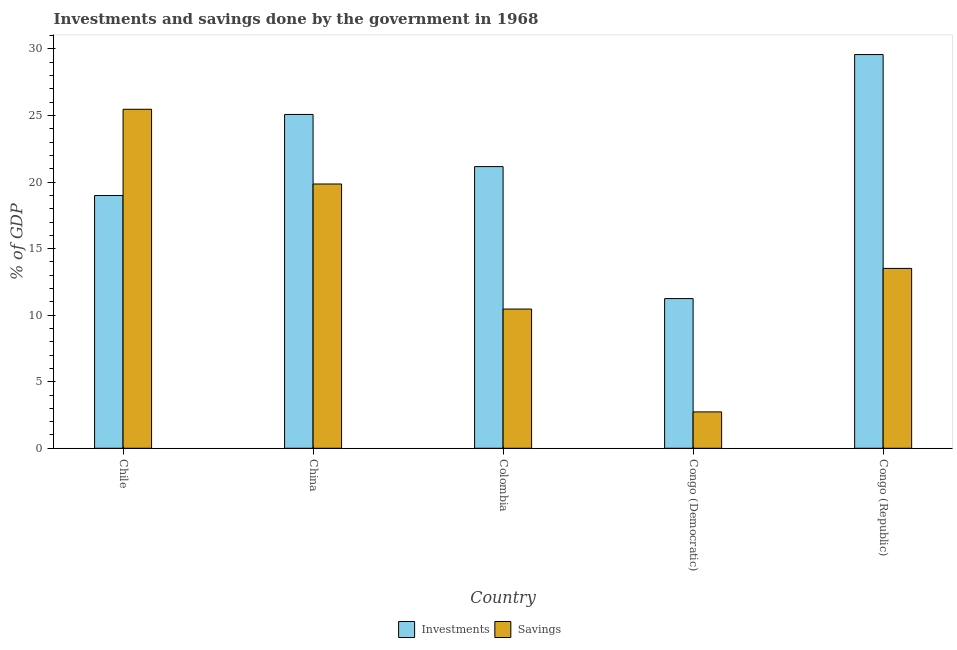How many different coloured bars are there?
Offer a very short reply. 2. How many bars are there on the 1st tick from the left?
Your answer should be compact. 2. What is the label of the 4th group of bars from the left?
Your response must be concise. Congo (Democratic). What is the investments of government in Chile?
Offer a very short reply. 18.99. Across all countries, what is the maximum investments of government?
Your response must be concise. 29.58. Across all countries, what is the minimum investments of government?
Keep it short and to the point. 11.25. In which country was the investments of government maximum?
Your answer should be compact. Congo (Republic). In which country was the savings of government minimum?
Make the answer very short. Congo (Democratic). What is the total savings of government in the graph?
Your answer should be compact. 72.04. What is the difference between the savings of government in China and that in Congo (Republic)?
Offer a terse response. 6.34. What is the difference between the savings of government in China and the investments of government in Colombia?
Give a very brief answer. -1.31. What is the average savings of government per country?
Offer a terse response. 14.41. What is the difference between the investments of government and savings of government in Congo (Republic)?
Your answer should be very brief. 16.07. In how many countries, is the investments of government greater than 30 %?
Your response must be concise. 0. What is the ratio of the savings of government in China to that in Colombia?
Provide a short and direct response. 1.9. Is the investments of government in Congo (Democratic) less than that in Congo (Republic)?
Your answer should be very brief. Yes. Is the difference between the savings of government in Colombia and Congo (Democratic) greater than the difference between the investments of government in Colombia and Congo (Democratic)?
Your answer should be compact. No. What is the difference between the highest and the second highest savings of government?
Your answer should be very brief. 5.61. What is the difference between the highest and the lowest investments of government?
Offer a terse response. 18.33. What does the 1st bar from the left in Colombia represents?
Give a very brief answer. Investments. What does the 2nd bar from the right in Congo (Republic) represents?
Ensure brevity in your answer.  Investments. How many bars are there?
Keep it short and to the point. 10. How many countries are there in the graph?
Your response must be concise. 5. Are the values on the major ticks of Y-axis written in scientific E-notation?
Your answer should be compact. No. Does the graph contain any zero values?
Your answer should be compact. No. How are the legend labels stacked?
Offer a terse response. Horizontal. What is the title of the graph?
Offer a very short reply. Investments and savings done by the government in 1968. Does "RDB nonconcessional" appear as one of the legend labels in the graph?
Provide a short and direct response. No. What is the label or title of the Y-axis?
Offer a terse response. % of GDP. What is the % of GDP of Investments in Chile?
Your response must be concise. 18.99. What is the % of GDP of Savings in Chile?
Make the answer very short. 25.47. What is the % of GDP in Investments in China?
Ensure brevity in your answer.  25.08. What is the % of GDP of Savings in China?
Your answer should be very brief. 19.86. What is the % of GDP in Investments in Colombia?
Offer a terse response. 21.16. What is the % of GDP of Savings in Colombia?
Provide a short and direct response. 10.46. What is the % of GDP of Investments in Congo (Democratic)?
Offer a very short reply. 11.25. What is the % of GDP in Savings in Congo (Democratic)?
Keep it short and to the point. 2.73. What is the % of GDP in Investments in Congo (Republic)?
Provide a short and direct response. 29.58. What is the % of GDP of Savings in Congo (Republic)?
Provide a short and direct response. 13.52. Across all countries, what is the maximum % of GDP of Investments?
Offer a terse response. 29.58. Across all countries, what is the maximum % of GDP of Savings?
Your response must be concise. 25.47. Across all countries, what is the minimum % of GDP in Investments?
Your answer should be very brief. 11.25. Across all countries, what is the minimum % of GDP in Savings?
Give a very brief answer. 2.73. What is the total % of GDP in Investments in the graph?
Make the answer very short. 106.07. What is the total % of GDP in Savings in the graph?
Offer a very short reply. 72.04. What is the difference between the % of GDP in Investments in Chile and that in China?
Offer a very short reply. -6.09. What is the difference between the % of GDP in Savings in Chile and that in China?
Your answer should be very brief. 5.61. What is the difference between the % of GDP of Investments in Chile and that in Colombia?
Your answer should be very brief. -2.17. What is the difference between the % of GDP in Savings in Chile and that in Colombia?
Your answer should be very brief. 15.01. What is the difference between the % of GDP in Investments in Chile and that in Congo (Democratic)?
Offer a very short reply. 7.75. What is the difference between the % of GDP in Savings in Chile and that in Congo (Democratic)?
Offer a very short reply. 22.74. What is the difference between the % of GDP in Investments in Chile and that in Congo (Republic)?
Ensure brevity in your answer.  -10.59. What is the difference between the % of GDP in Savings in Chile and that in Congo (Republic)?
Ensure brevity in your answer.  11.96. What is the difference between the % of GDP in Investments in China and that in Colombia?
Make the answer very short. 3.92. What is the difference between the % of GDP in Savings in China and that in Colombia?
Keep it short and to the point. 9.4. What is the difference between the % of GDP of Investments in China and that in Congo (Democratic)?
Offer a terse response. 13.84. What is the difference between the % of GDP of Savings in China and that in Congo (Democratic)?
Make the answer very short. 17.12. What is the difference between the % of GDP in Investments in China and that in Congo (Republic)?
Provide a short and direct response. -4.5. What is the difference between the % of GDP of Savings in China and that in Congo (Republic)?
Provide a succinct answer. 6.34. What is the difference between the % of GDP in Investments in Colombia and that in Congo (Democratic)?
Your answer should be very brief. 9.92. What is the difference between the % of GDP of Savings in Colombia and that in Congo (Democratic)?
Your answer should be very brief. 7.73. What is the difference between the % of GDP of Investments in Colombia and that in Congo (Republic)?
Keep it short and to the point. -8.42. What is the difference between the % of GDP in Savings in Colombia and that in Congo (Republic)?
Offer a terse response. -3.05. What is the difference between the % of GDP in Investments in Congo (Democratic) and that in Congo (Republic)?
Offer a terse response. -18.33. What is the difference between the % of GDP of Savings in Congo (Democratic) and that in Congo (Republic)?
Keep it short and to the point. -10.78. What is the difference between the % of GDP in Investments in Chile and the % of GDP in Savings in China?
Your answer should be compact. -0.86. What is the difference between the % of GDP of Investments in Chile and the % of GDP of Savings in Colombia?
Your answer should be compact. 8.53. What is the difference between the % of GDP in Investments in Chile and the % of GDP in Savings in Congo (Democratic)?
Keep it short and to the point. 16.26. What is the difference between the % of GDP of Investments in Chile and the % of GDP of Savings in Congo (Republic)?
Your answer should be compact. 5.48. What is the difference between the % of GDP in Investments in China and the % of GDP in Savings in Colombia?
Offer a very short reply. 14.62. What is the difference between the % of GDP in Investments in China and the % of GDP in Savings in Congo (Democratic)?
Ensure brevity in your answer.  22.35. What is the difference between the % of GDP of Investments in China and the % of GDP of Savings in Congo (Republic)?
Give a very brief answer. 11.57. What is the difference between the % of GDP of Investments in Colombia and the % of GDP of Savings in Congo (Democratic)?
Ensure brevity in your answer.  18.43. What is the difference between the % of GDP of Investments in Colombia and the % of GDP of Savings in Congo (Republic)?
Provide a succinct answer. 7.65. What is the difference between the % of GDP in Investments in Congo (Democratic) and the % of GDP in Savings in Congo (Republic)?
Provide a short and direct response. -2.27. What is the average % of GDP of Investments per country?
Provide a short and direct response. 21.21. What is the average % of GDP of Savings per country?
Make the answer very short. 14.41. What is the difference between the % of GDP in Investments and % of GDP in Savings in Chile?
Your answer should be compact. -6.48. What is the difference between the % of GDP in Investments and % of GDP in Savings in China?
Keep it short and to the point. 5.23. What is the difference between the % of GDP in Investments and % of GDP in Savings in Colombia?
Ensure brevity in your answer.  10.7. What is the difference between the % of GDP in Investments and % of GDP in Savings in Congo (Democratic)?
Keep it short and to the point. 8.51. What is the difference between the % of GDP in Investments and % of GDP in Savings in Congo (Republic)?
Offer a very short reply. 16.07. What is the ratio of the % of GDP in Investments in Chile to that in China?
Provide a short and direct response. 0.76. What is the ratio of the % of GDP of Savings in Chile to that in China?
Keep it short and to the point. 1.28. What is the ratio of the % of GDP in Investments in Chile to that in Colombia?
Make the answer very short. 0.9. What is the ratio of the % of GDP of Savings in Chile to that in Colombia?
Keep it short and to the point. 2.43. What is the ratio of the % of GDP in Investments in Chile to that in Congo (Democratic)?
Offer a very short reply. 1.69. What is the ratio of the % of GDP in Savings in Chile to that in Congo (Democratic)?
Provide a short and direct response. 9.32. What is the ratio of the % of GDP of Investments in Chile to that in Congo (Republic)?
Provide a short and direct response. 0.64. What is the ratio of the % of GDP in Savings in Chile to that in Congo (Republic)?
Your response must be concise. 1.88. What is the ratio of the % of GDP of Investments in China to that in Colombia?
Keep it short and to the point. 1.19. What is the ratio of the % of GDP of Savings in China to that in Colombia?
Provide a short and direct response. 1.9. What is the ratio of the % of GDP of Investments in China to that in Congo (Democratic)?
Provide a succinct answer. 2.23. What is the ratio of the % of GDP of Savings in China to that in Congo (Democratic)?
Give a very brief answer. 7.27. What is the ratio of the % of GDP in Investments in China to that in Congo (Republic)?
Keep it short and to the point. 0.85. What is the ratio of the % of GDP of Savings in China to that in Congo (Republic)?
Offer a terse response. 1.47. What is the ratio of the % of GDP of Investments in Colombia to that in Congo (Democratic)?
Keep it short and to the point. 1.88. What is the ratio of the % of GDP in Savings in Colombia to that in Congo (Democratic)?
Offer a terse response. 3.83. What is the ratio of the % of GDP of Investments in Colombia to that in Congo (Republic)?
Offer a terse response. 0.72. What is the ratio of the % of GDP in Savings in Colombia to that in Congo (Republic)?
Make the answer very short. 0.77. What is the ratio of the % of GDP in Investments in Congo (Democratic) to that in Congo (Republic)?
Offer a terse response. 0.38. What is the ratio of the % of GDP of Savings in Congo (Democratic) to that in Congo (Republic)?
Offer a very short reply. 0.2. What is the difference between the highest and the second highest % of GDP of Investments?
Ensure brevity in your answer.  4.5. What is the difference between the highest and the second highest % of GDP of Savings?
Your answer should be very brief. 5.61. What is the difference between the highest and the lowest % of GDP of Investments?
Give a very brief answer. 18.33. What is the difference between the highest and the lowest % of GDP of Savings?
Make the answer very short. 22.74. 